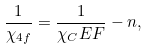Convert formula to latex. <formula><loc_0><loc_0><loc_500><loc_500>\frac { 1 } { \chi _ { 4 f } } = \frac { 1 } { \chi _ { C } E F } - n ,</formula> 